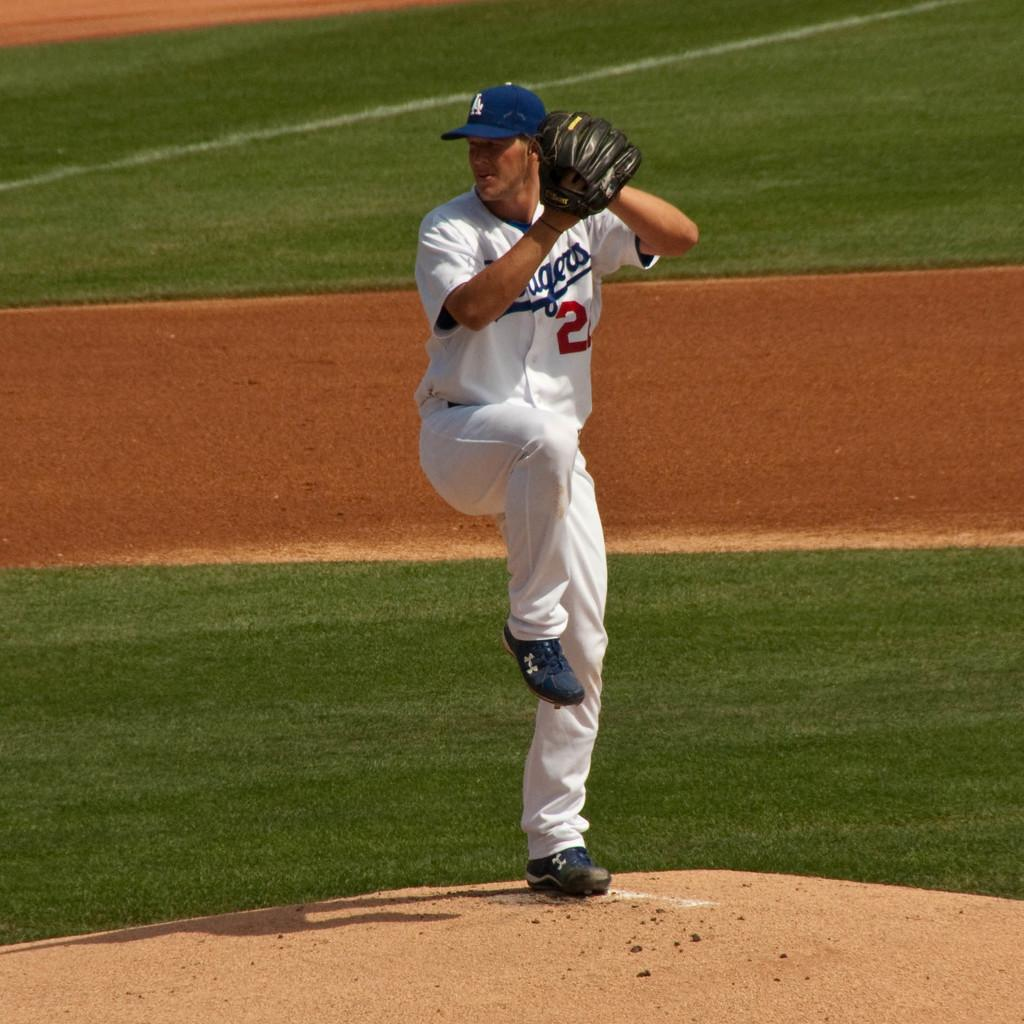<image>
Share a concise interpretation of the image provided. the number 2 is on the jersey of a player 